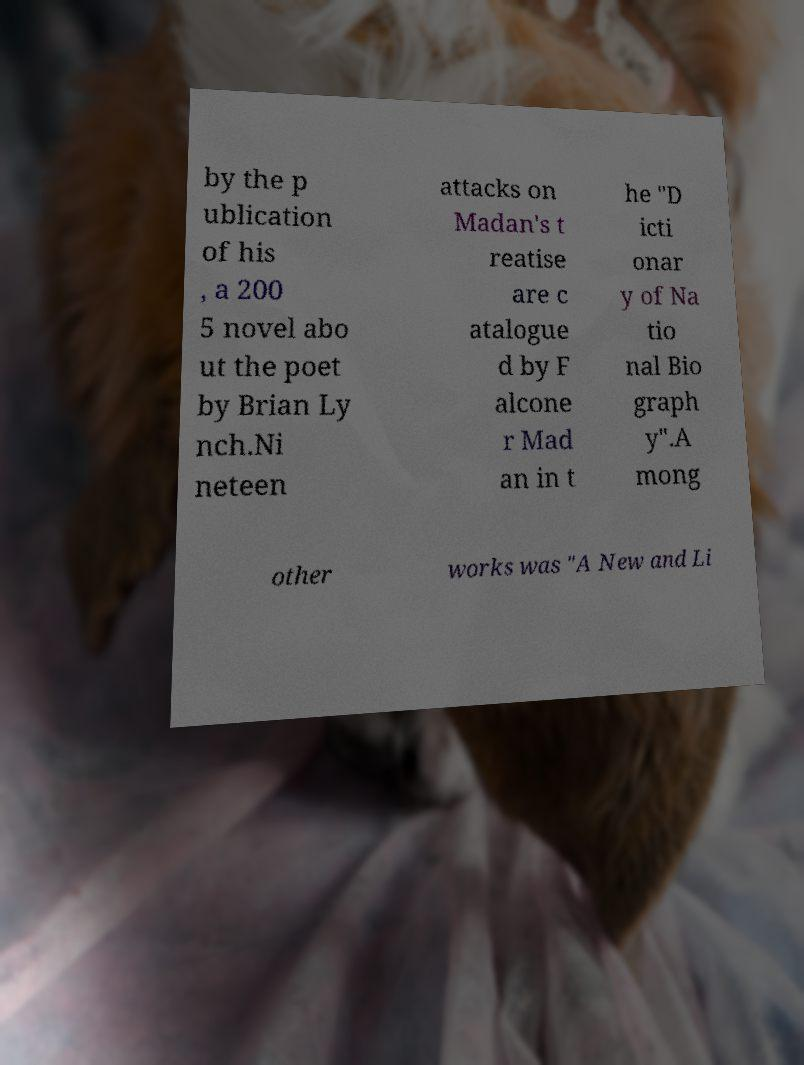Can you accurately transcribe the text from the provided image for me? by the p ublication of his , a 200 5 novel abo ut the poet by Brian Ly nch.Ni neteen attacks on Madan's t reatise are c atalogue d by F alcone r Mad an in t he "D icti onar y of Na tio nal Bio graph y".A mong other works was "A New and Li 